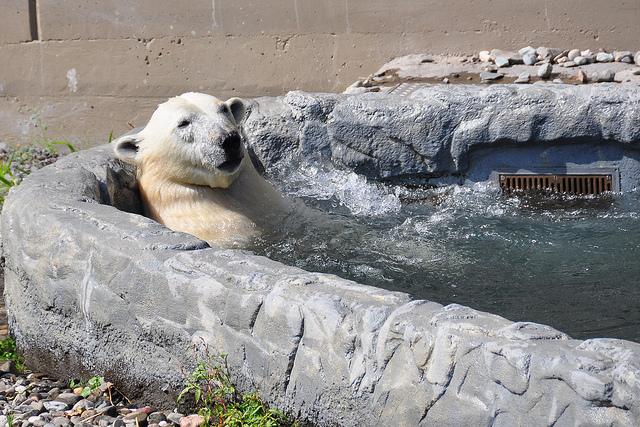How old does the bear look?
Short answer required. Old. Is the bear cooling off?
Answer briefly. Yes. What is the polar bear doing?
Be succinct. Swimming. What brand typically uses this animal in its advertisements?
Concise answer only. Coke. 